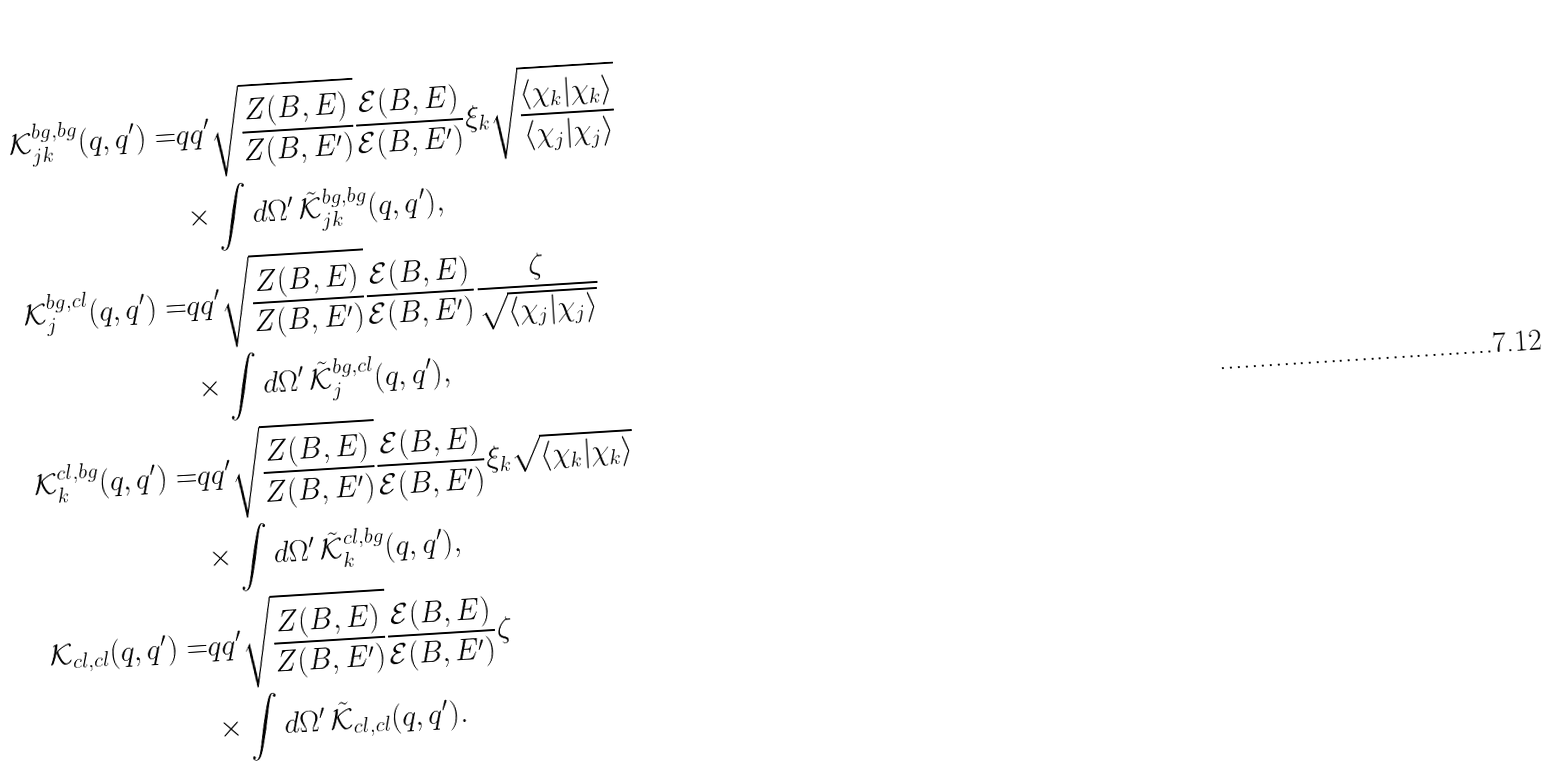<formula> <loc_0><loc_0><loc_500><loc_500>\mathcal { K } _ { j k } ^ { b g , b g } ( q , q ^ { \prime } ) = & q q ^ { \prime } \sqrt { \frac { Z ( B , E ) } { Z ( B , E ^ { \prime } ) } } \frac { \mathcal { E } ( B , E ) } { \mathcal { E } ( B , E ^ { \prime } ) } \xi _ { k } \sqrt { \frac { \langle \chi _ { k } | \chi _ { k } \rangle } { \langle \chi _ { j } | \chi _ { j } \rangle } } \\ & \times \int d \Omega ^ { \prime } \, \tilde { \mathcal { K } } _ { j k } ^ { b g , b g } ( q , q ^ { \prime } ) , \\ \mathcal { K } _ { j } ^ { b g , c l } ( q , q ^ { \prime } ) = & q q ^ { \prime } \sqrt { \frac { Z ( B , E ) } { Z ( B , E ^ { \prime } ) } } \frac { \mathcal { E } ( B , E ) } { \mathcal { E } ( B , E ^ { \prime } ) } \frac { \zeta } { \sqrt { \langle \chi _ { j } | \chi _ { j } \rangle } } \\ & \times \int d \Omega ^ { \prime } \, \tilde { \mathcal { K } } _ { j } ^ { b g , c l } ( q , q ^ { \prime } ) , \\ \mathcal { K } _ { k } ^ { c l , b g } ( q , q ^ { \prime } ) = & q q ^ { \prime } \sqrt { \frac { Z ( B , E ) } { Z ( B , E ^ { \prime } ) } } \frac { \mathcal { E } ( B , E ) } { \mathcal { E } ( B , E ^ { \prime } ) } \xi _ { k } \sqrt { \langle \chi _ { k } | \chi _ { k } \rangle } \\ & \times \int d \Omega ^ { \prime } \, \tilde { \mathcal { K } } _ { k } ^ { c l , b g } ( q , q ^ { \prime } ) , \\ \mathcal { K } _ { c l , c l } ( q , q ^ { \prime } ) = & q q ^ { \prime } \sqrt { \frac { Z ( B , E ) } { Z ( B , E ^ { \prime } ) } } \frac { \mathcal { E } ( B , E ) } { \mathcal { E } ( B , E ^ { \prime } ) } \zeta \\ & \times \int d \Omega ^ { \prime } \, \tilde { \mathcal { K } } _ { c l , c l } ( q , q ^ { \prime } ) .</formula> 